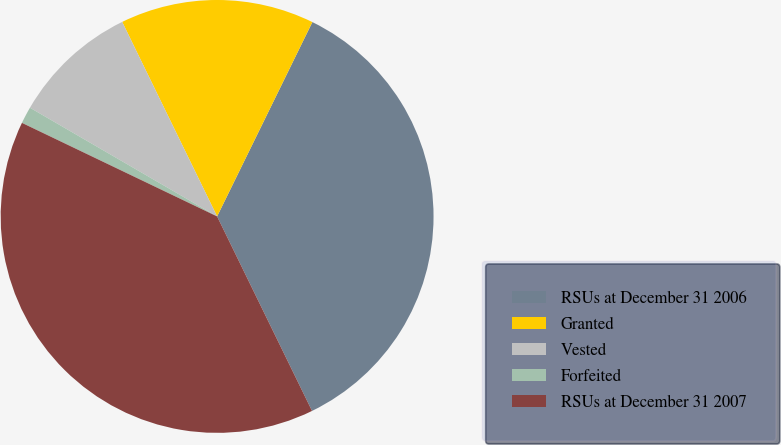<chart> <loc_0><loc_0><loc_500><loc_500><pie_chart><fcel>RSUs at December 31 2006<fcel>Granted<fcel>Vested<fcel>Forfeited<fcel>RSUs at December 31 2007<nl><fcel>35.52%<fcel>14.48%<fcel>9.4%<fcel>1.26%<fcel>39.34%<nl></chart> 